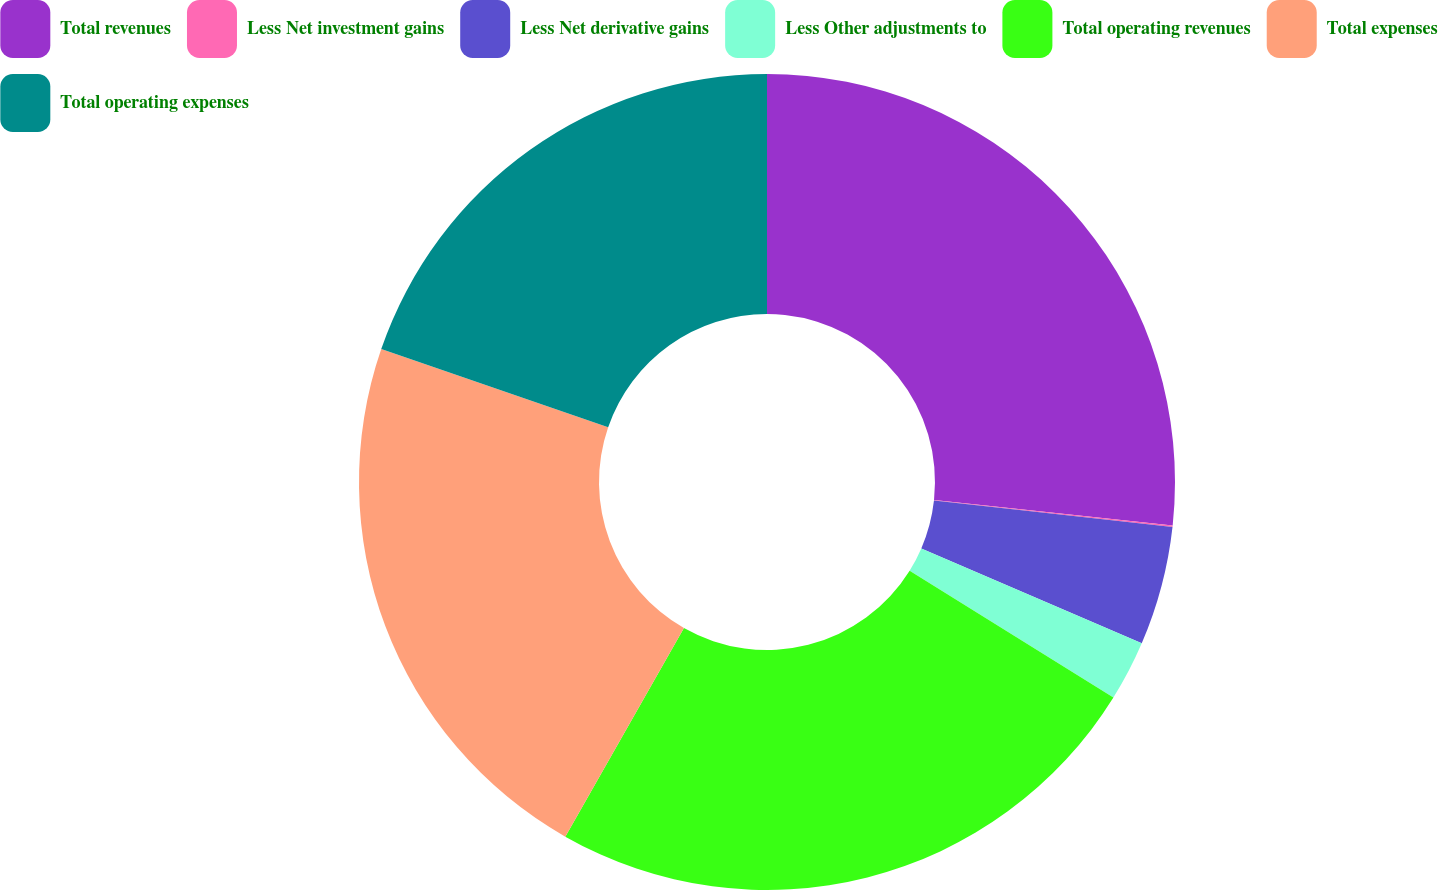Convert chart. <chart><loc_0><loc_0><loc_500><loc_500><pie_chart><fcel>Total revenues<fcel>Less Net investment gains<fcel>Less Net derivative gains<fcel>Less Other adjustments to<fcel>Total operating revenues<fcel>Total expenses<fcel>Total operating expenses<nl><fcel>26.7%<fcel>0.06%<fcel>4.71%<fcel>2.39%<fcel>24.37%<fcel>22.05%<fcel>19.72%<nl></chart> 